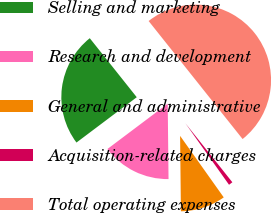<chart> <loc_0><loc_0><loc_500><loc_500><pie_chart><fcel>Selling and marketing<fcel>Research and development<fcel>General and administrative<fcel>Acquisition-related charges<fcel>Total operating expenses<nl><fcel>24.56%<fcel>14.91%<fcel>9.65%<fcel>0.88%<fcel>50.0%<nl></chart> 